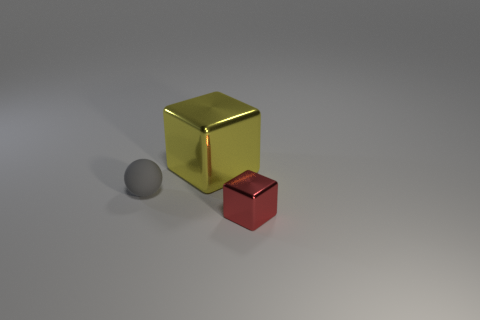Does the size of these objects affect their apparent usefulness? In practical terms, the size of an object can greatly impact its usefulness, depending on the object's intended function. The larger yellow object in the image could be more versatile due to its size, and could potentially be used for storage or as a container if it's hollow. The smaller red object could serve as a decorative item or a paperweight. Without knowing the exact material and solidity, it's speculation, but size often correlates with potential uses. Could the smaller object serve a different purpose if it were the same size as the larger one? Absolutely, if the smaller red object were the same size as the larger yellow one, it could potentially adopt a broader range of functions similar to those mentioned for the yellow object. Its larger surface area and volume could lend itself to a variety of uses, from storage to being an integral part in a larger construction. 